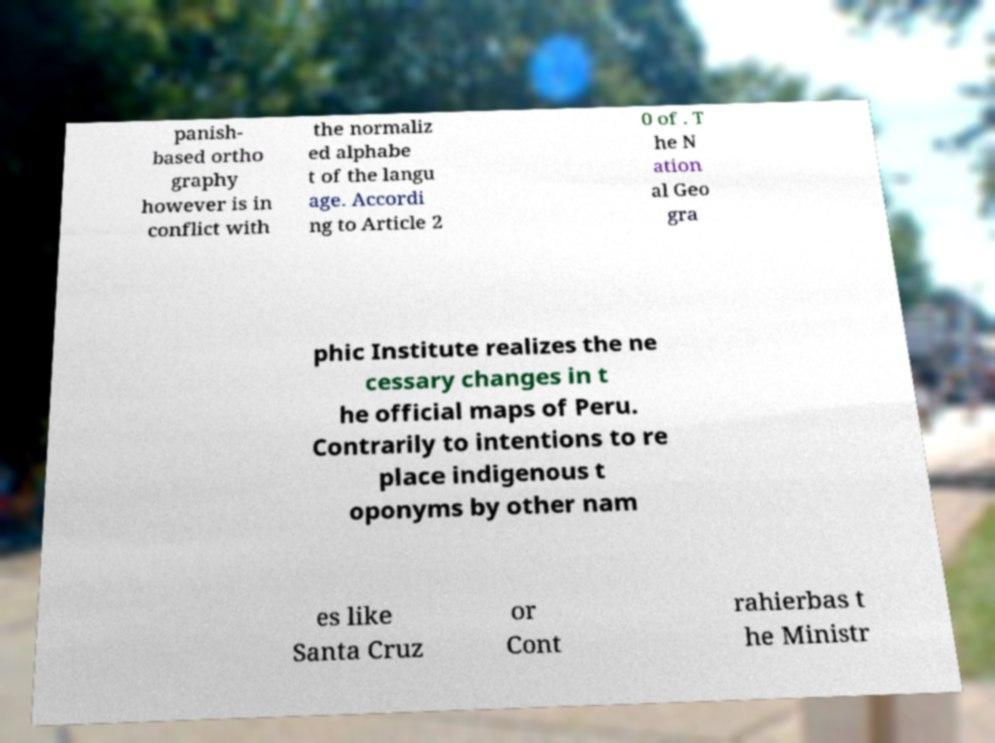Can you accurately transcribe the text from the provided image for me? panish- based ortho graphy however is in conflict with the normaliz ed alphabe t of the langu age. Accordi ng to Article 2 0 of . T he N ation al Geo gra phic Institute realizes the ne cessary changes in t he official maps of Peru. Contrarily to intentions to re place indigenous t oponyms by other nam es like Santa Cruz or Cont rahierbas t he Ministr 